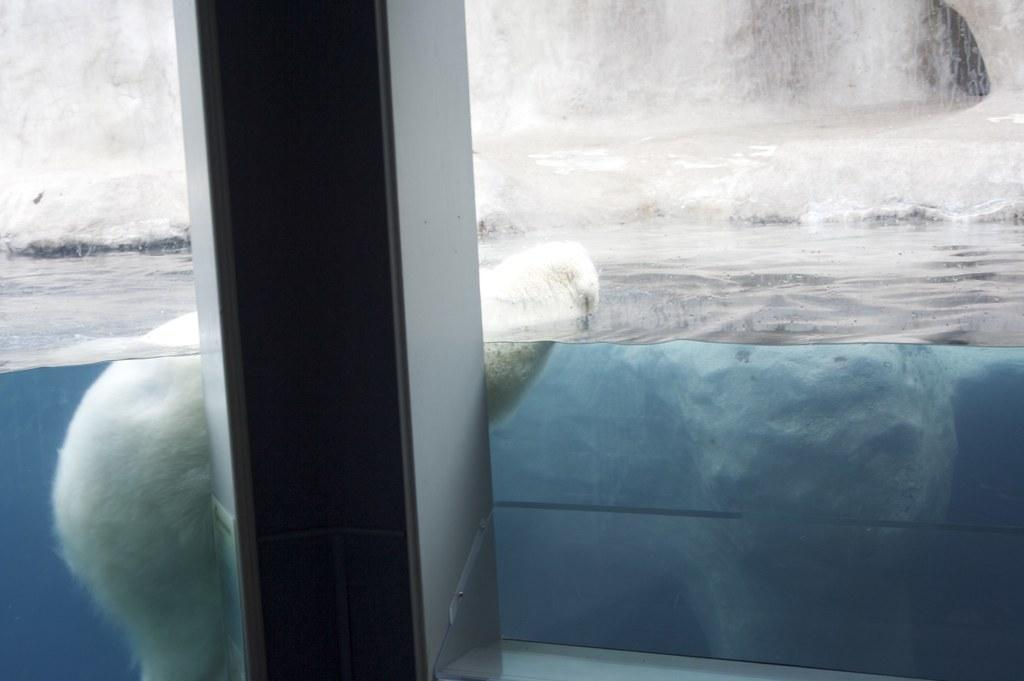What is the animal doing in the water? The fact does not specify what the animal is doing, only that it is in the water. Can you describe the unspecified object in the image? Unfortunately, the fact only mentions that there is an unspecified object in the image, without providing any details about its appearance or characteristics. What type of plate is being used by the dad in the image? There is no dad or plate present in the image, as the facts only mention an animal in the water and an unspecified object. 